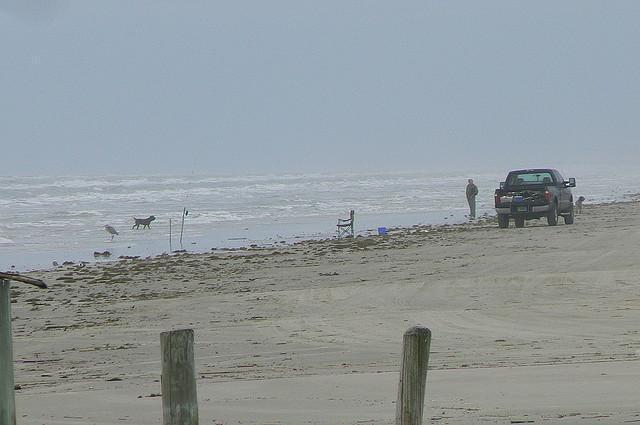How many animals are in the water?
Give a very brief answer. 2. How many birds are in the photo?
Give a very brief answer. 1. How many green cars in the picture?
Give a very brief answer. 0. 